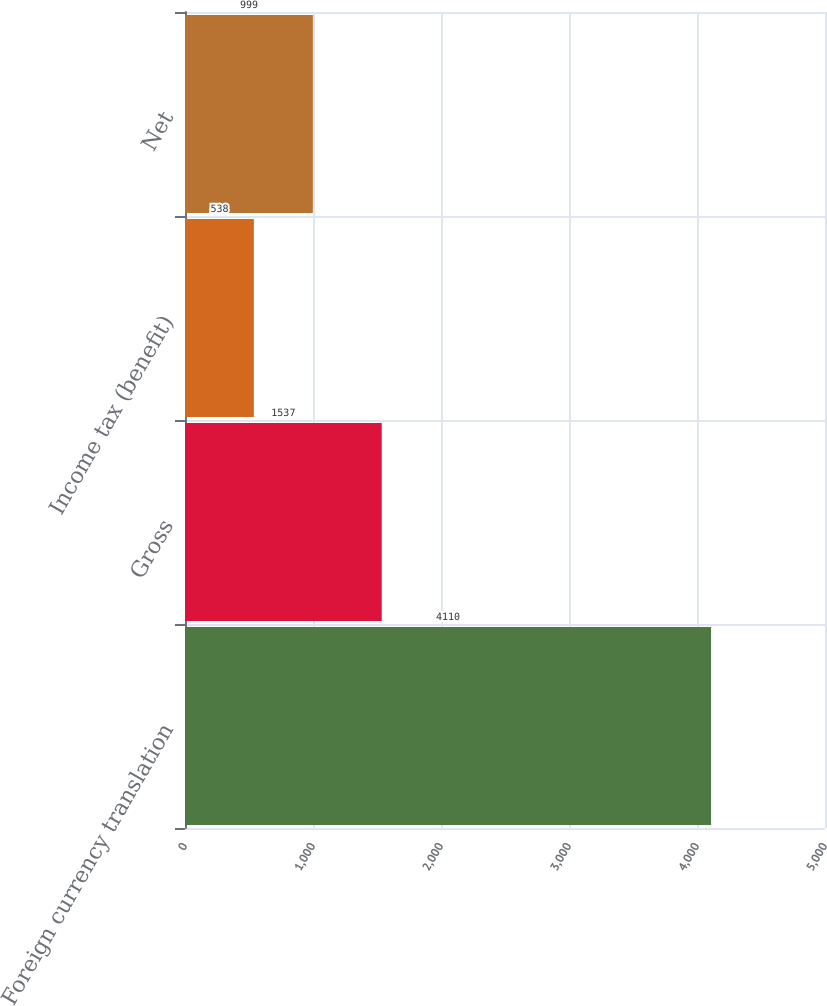Convert chart. <chart><loc_0><loc_0><loc_500><loc_500><bar_chart><fcel>Foreign currency translation<fcel>Gross<fcel>Income tax (benefit)<fcel>Net<nl><fcel>4110<fcel>1537<fcel>538<fcel>999<nl></chart> 